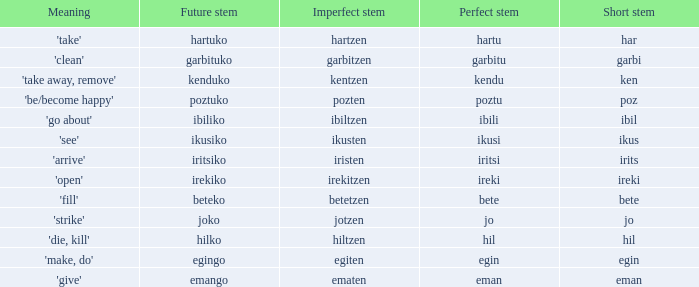What is the perfect stem for pozten? Poztu. 